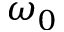<formula> <loc_0><loc_0><loc_500><loc_500>\omega _ { 0 }</formula> 